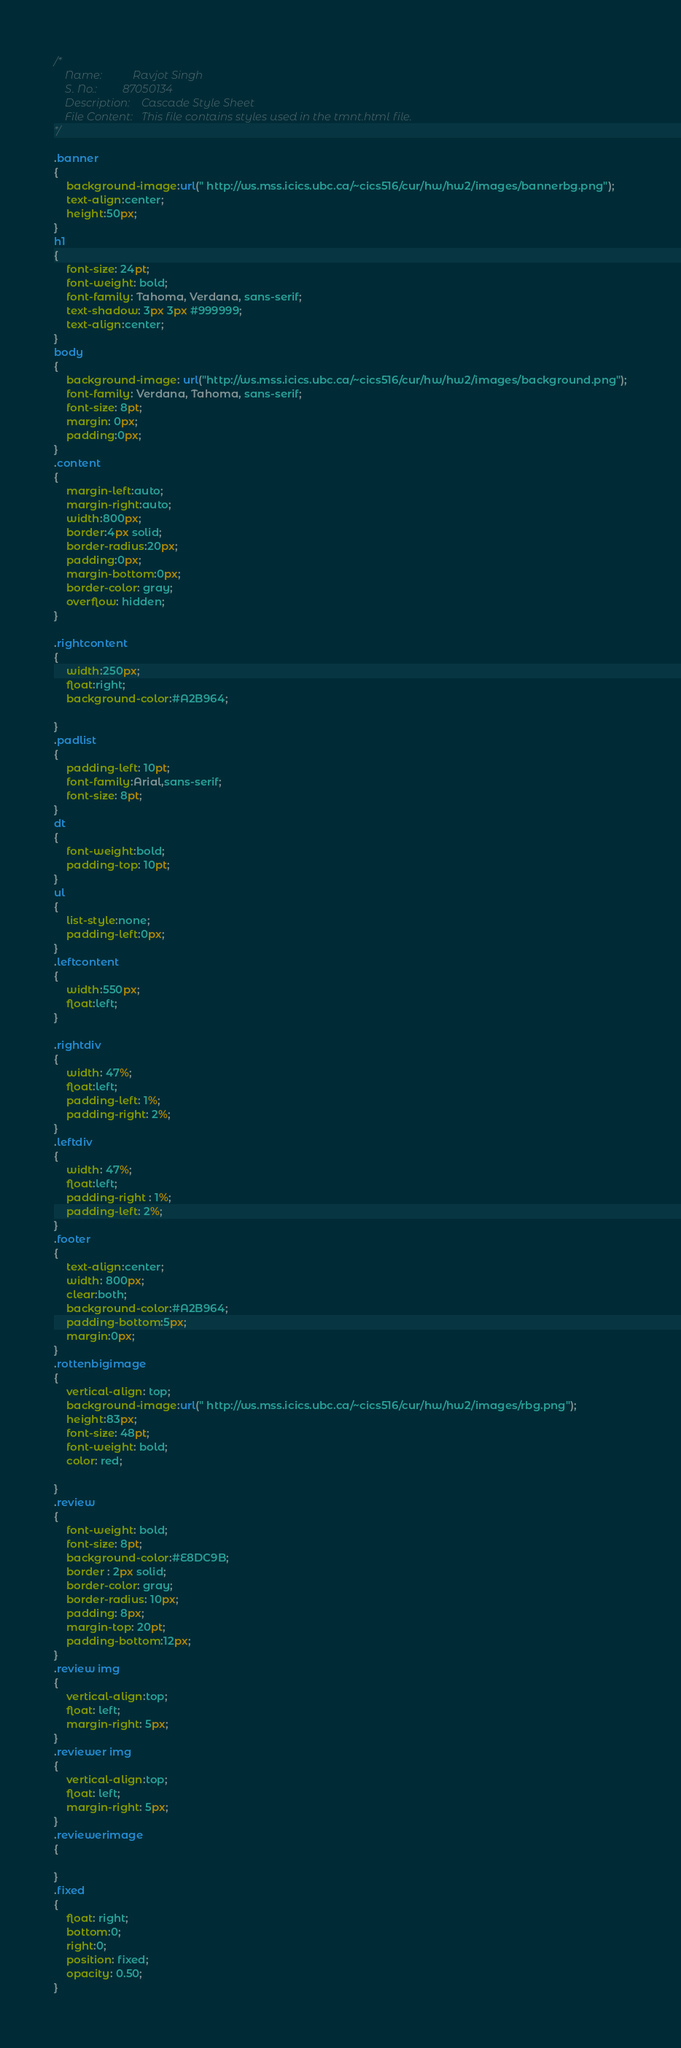Convert code to text. <code><loc_0><loc_0><loc_500><loc_500><_CSS_>/*
	Name: 			Ravjot Singh
	S. No.:			87050134
	Description:	Cascade Style Sheet
	File Content:	This file contains styles used in the tmnt.html file.
*/

.banner
{
	background-image:url(" http://ws.mss.icics.ubc.ca/~cics516/cur/hw/hw2/images/bannerbg.png");
	text-align:center;
	height:50px;
}
h1
{
	font-size: 24pt;
	font-weight: bold;
	font-family: Tahoma, Verdana, sans-serif;
	text-shadow: 3px 3px #999999;
	text-align:center;
}
body
{
	background-image: url("http://ws.mss.icics.ubc.ca/~cics516/cur/hw/hw2/images/background.png");
	font-family: Verdana, Tahoma, sans-serif;
	font-size: 8pt;
	margin: 0px;
	padding:0px;
}
.content
{
	margin-left:auto;
	margin-right:auto;	
	width:800px;
	border:4px solid;
	border-radius:20px;
	padding:0px;
	margin-bottom:0px;
	border-color: gray;
	overflow: hidden;
}

.rightcontent
{
	width:250px;
	float:right;
	background-color:#A2B964;
	
}
.padlist
{
	padding-left: 10pt;
	font-family:Arial,sans-serif;
	font-size: 8pt;
}
dt
{
	font-weight:bold;
	padding-top: 10pt;
}
ul
{
	list-style:none;
	padding-left:0px;
}
.leftcontent
{
	width:550px;
	float:left;
}

.rightdiv
{
	width: 47%;
	float:left;
	padding-left: 1%;
	padding-right: 2%;
}
.leftdiv
{
	width: 47%;
	float:left;
	padding-right : 1%;
	padding-left: 2%;
}
.footer
{
	text-align:center;
	width: 800px;
	clear:both;
	background-color:#A2B964;
	padding-bottom:5px;
	margin:0px;
}
.rottenbigimage
{
	vertical-align: top;
	background-image:url(" http://ws.mss.icics.ubc.ca/~cics516/cur/hw/hw2/images/rbg.png");
	height:83px;
	font-size: 48pt;
	font-weight: bold;
	color: red;
	
}
.review
{
	font-weight: bold;
	font-size: 8pt;
	background-color:#E8DC9B;
	border : 2px solid;
	border-color: gray;
	border-radius: 10px;
	padding: 8px;
	margin-top: 20pt;
	padding-bottom:12px;
}
.review img
{
	vertical-align:top;
	float: left;
	margin-right: 5px;
}
.reviewer img
{
	vertical-align:top;
	float: left;
	margin-right: 5px;
}
.reviewerimage
{
	
}
.fixed
{
	float: right;
	bottom:0;
	right:0;
	position: fixed;
	opacity: 0.50;
}
</code> 